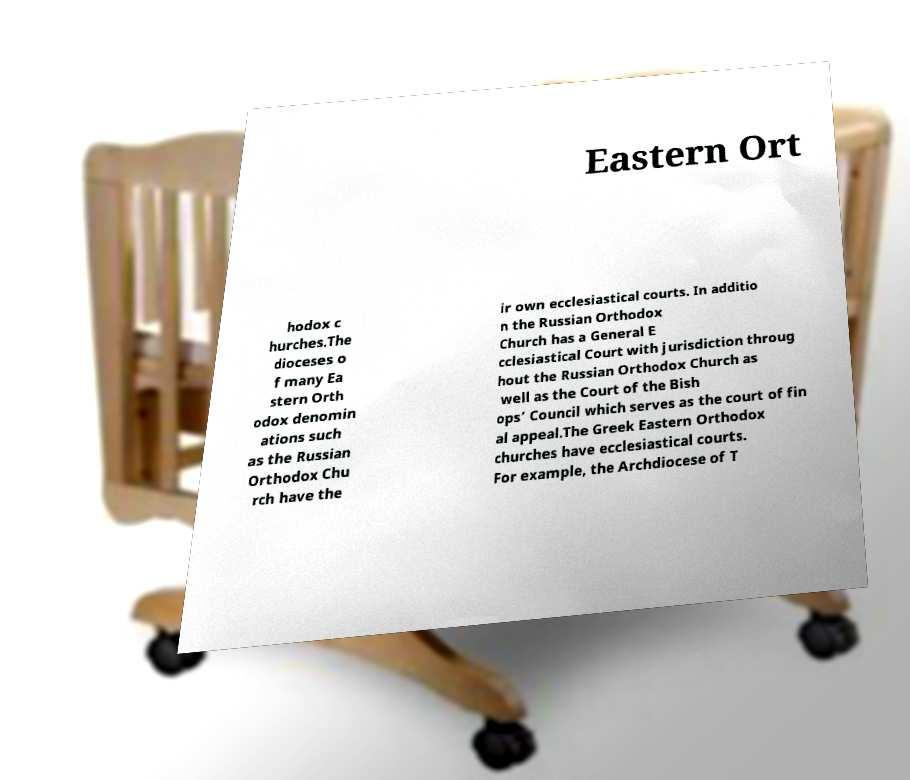What messages or text are displayed in this image? I need them in a readable, typed format. Eastern Ort hodox c hurches.The dioceses o f many Ea stern Orth odox denomin ations such as the Russian Orthodox Chu rch have the ir own ecclesiastical courts. In additio n the Russian Orthodox Church has a General E cclesiastical Court with jurisdiction throug hout the Russian Orthodox Church as well as the Court of the Bish ops’ Council which serves as the court of fin al appeal.The Greek Eastern Orthodox churches have ecclesiastical courts. For example, the Archdiocese of T 